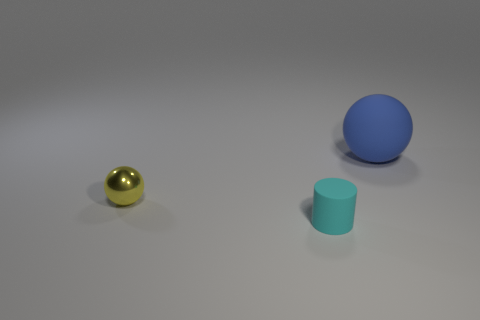Add 2 small yellow spheres. How many objects exist? 5 Subtract all balls. How many objects are left? 1 Subtract 0 red balls. How many objects are left? 3 Subtract all large matte things. Subtract all blue matte spheres. How many objects are left? 1 Add 3 cylinders. How many cylinders are left? 4 Add 3 big blue matte things. How many big blue matte things exist? 4 